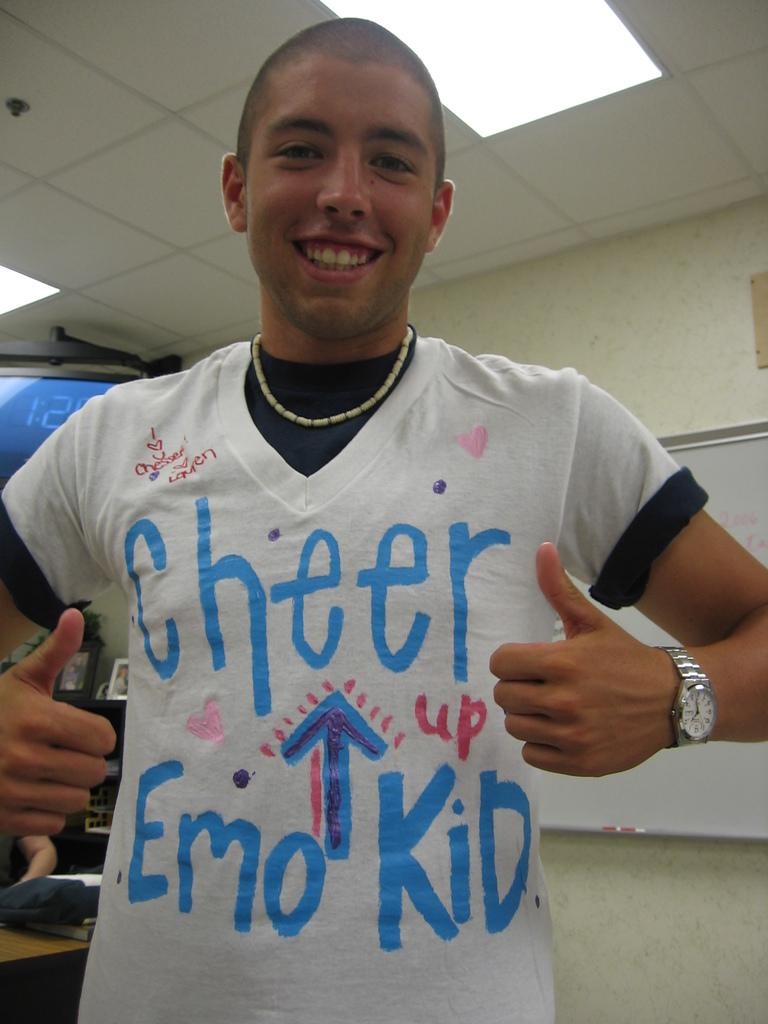What is the main subject of the image? There is a man standing in the image. What can be seen in the background of the image? There is a wall in the background of the image. What is above the man in the image? There is a ceiling visible in the image. What is providing light in the image? There is a light in the image. What type of meat is hanging from the ceiling in the image? There is no meat hanging from the ceiling in the image; it only features a man, a wall, a ceiling, and a light. 